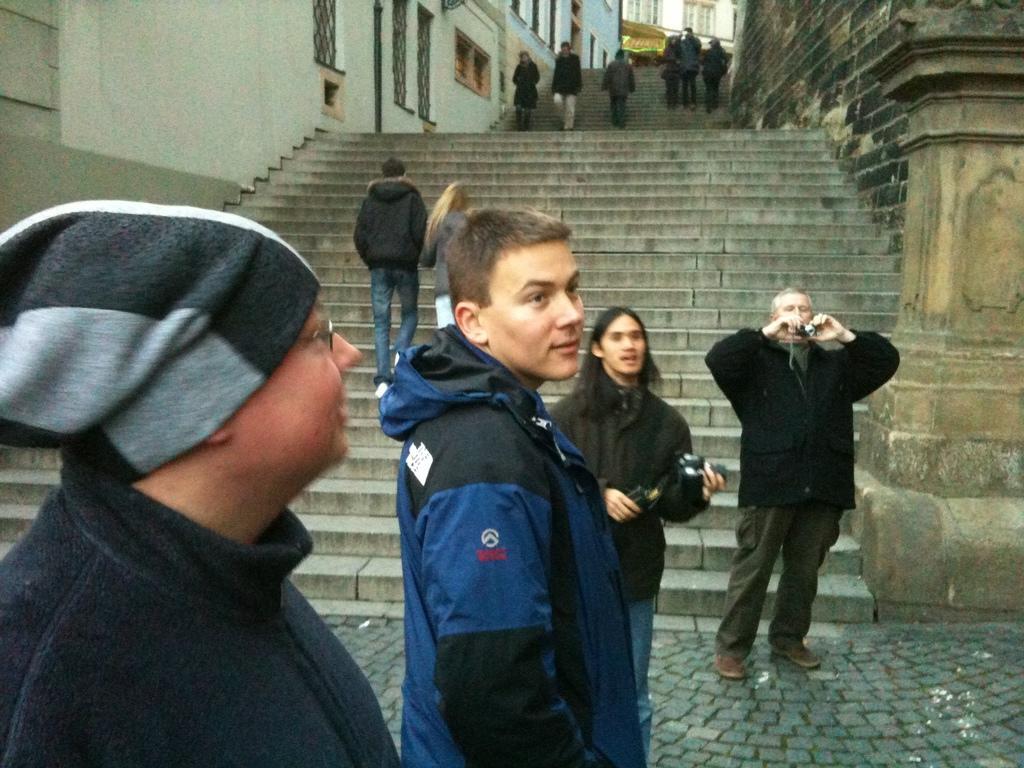Please provide a concise description of this image. There are some people standing. Some are holding camera. Person on the left is wearing a cap and specs. In the back there are steps. Some people are walking on the steps. On the sides of the steps there are walls. 